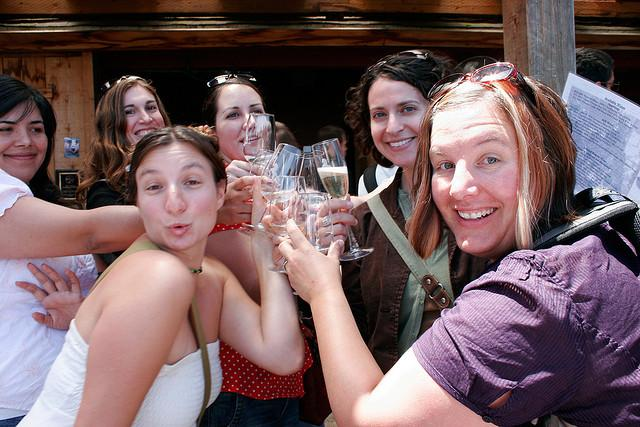What are the woman raising? Please explain your reasoning. glasses. They are celebrating. 